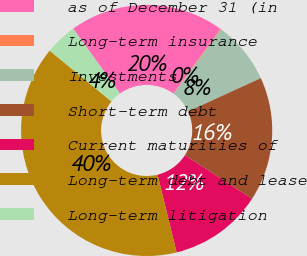<chart> <loc_0><loc_0><loc_500><loc_500><pie_chart><fcel>as of December 31 (in<fcel>Long-term insurance<fcel>Investments<fcel>Short-term debt<fcel>Current maturities of<fcel>Long-term debt and lease<fcel>Long-term litigation<nl><fcel>19.96%<fcel>0.11%<fcel>8.05%<fcel>15.99%<fcel>12.02%<fcel>39.8%<fcel>4.08%<nl></chart> 